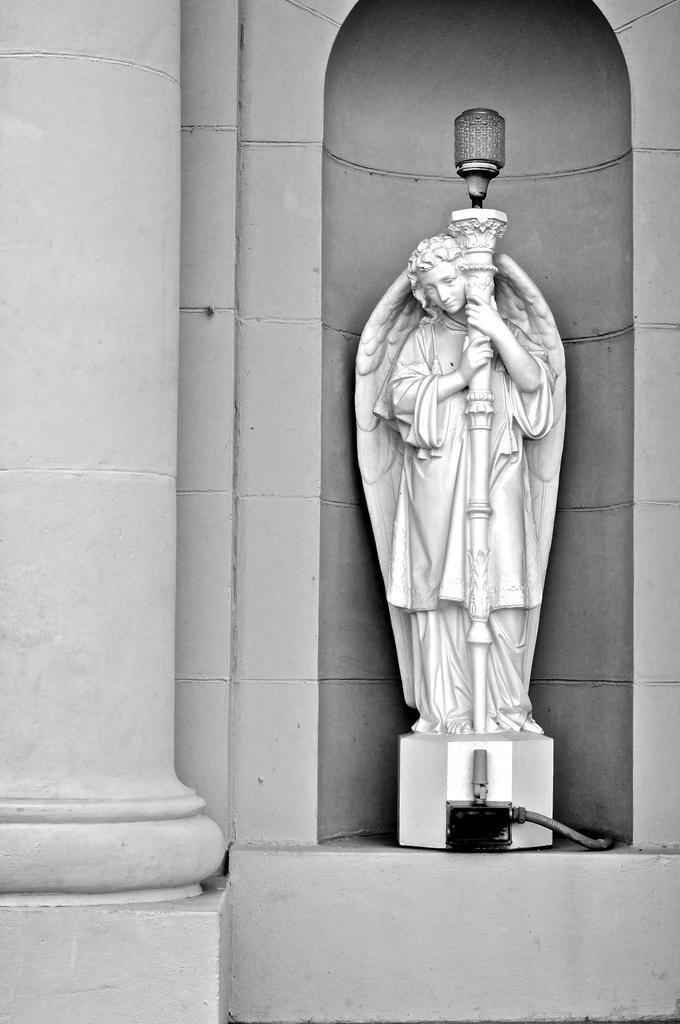Describe this image in one or two sentences. This is a black and white image. I can see a sculpture of a person with wings is standing and holding a light pole. On the left side of the image, this is a pillar. 